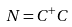Convert formula to latex. <formula><loc_0><loc_0><loc_500><loc_500>N = C ^ { + } C</formula> 